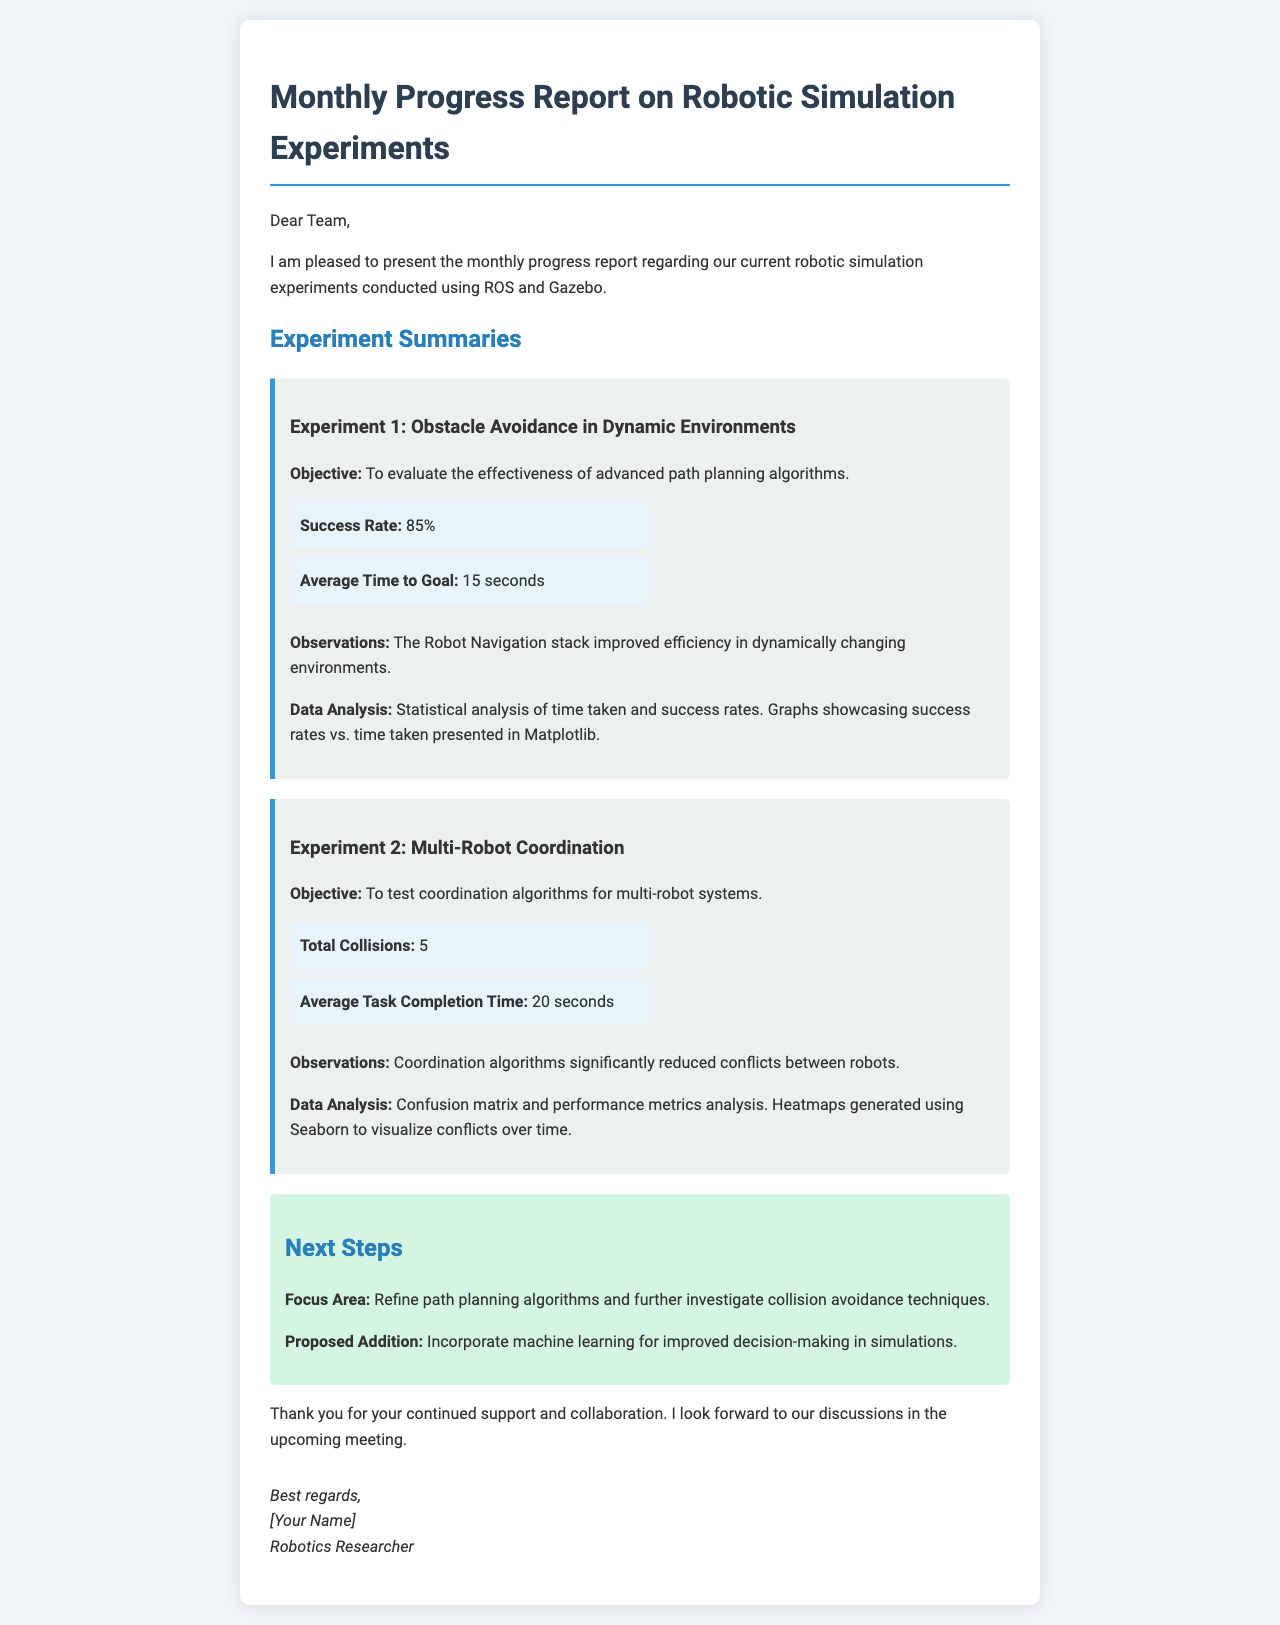What is the success rate for Experiment 1? The success rate for Experiment 1 is stated directly in the document as 85%.
Answer: 85% What is the average time to goal in Experiment 1? The document clearly mentions that the average time to goal for Experiment 1 is 15 seconds.
Answer: 15 seconds How many total collisions occurred in Experiment 2? The document indicates that there were 5 total collisions in Experiment 2.
Answer: 5 What is the average task completion time for Experiment 2? According to the document, the average task completion time for Experiment 2 is 20 seconds.
Answer: 20 seconds What are the next steps proposed in the report? The proposed next steps include refining path planning algorithms and further investigating collision avoidance techniques, as noted in the document.
Answer: Refine path planning algorithms and further investigate collision avoidance techniques What tools were used for data analysis in Experiment 1? The document specifies that statistical analysis and Matplotlib were used for data analysis in Experiment 1.
Answer: Matplotlib What is the objective of Experiment 2? The objective of Experiment 2 is explicitly stated in the document as testing coordination algorithms for multi-robot systems.
Answer: Test coordination algorithms for multi-robot systems How many observations are listed for Experiment 1? The document details one key observation for Experiment 1 regarding the Robot Navigation stack, indicating there is one observation listed.
Answer: 1 What type of data visualization was generated for Experiment 2? The document indicates that heatmaps were generated using Seaborn to visualize conflicts over time in Experiment 2.
Answer: Heatmaps 